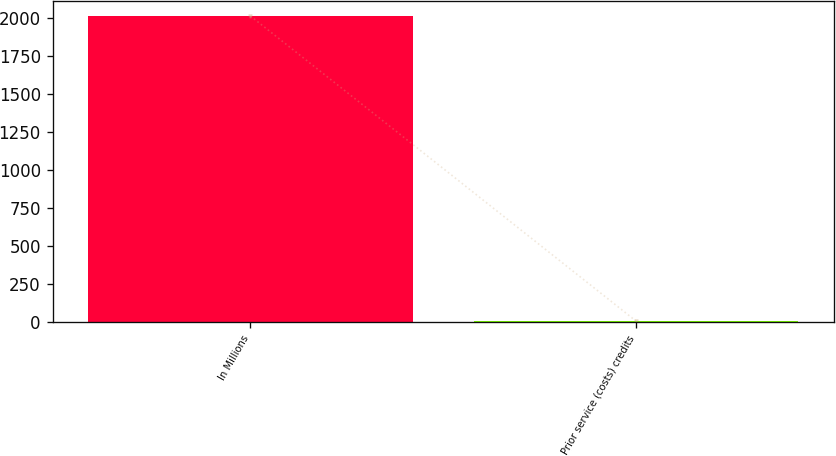<chart> <loc_0><loc_0><loc_500><loc_500><bar_chart><fcel>In Millions<fcel>Prior service (costs) credits<nl><fcel>2012<fcel>7.2<nl></chart> 